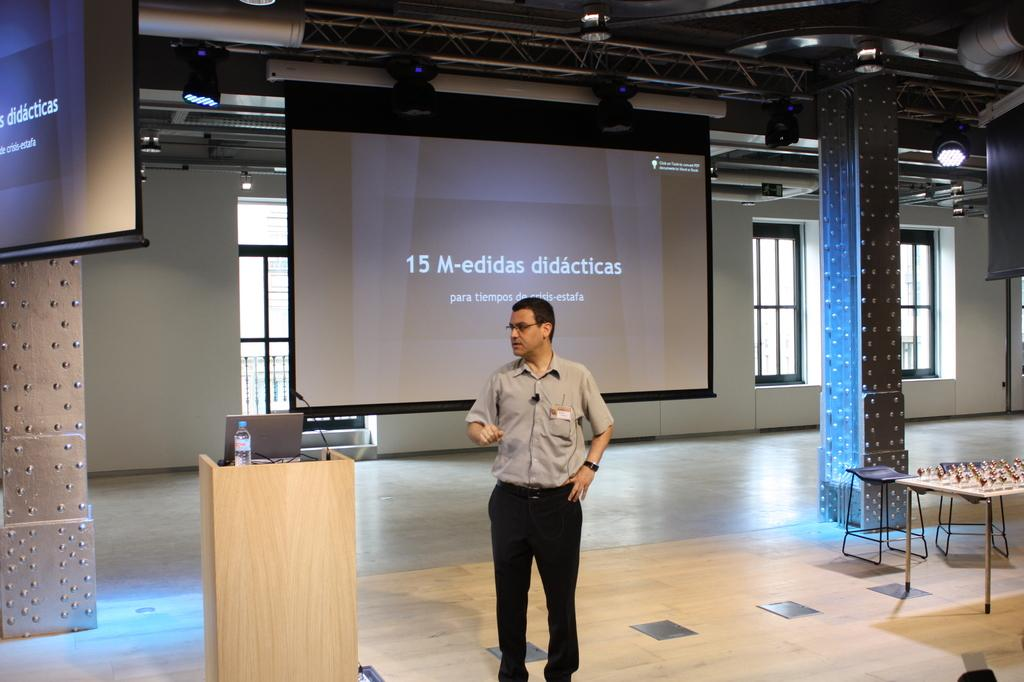<image>
Give a short and clear explanation of the subsequent image. A man standing in a building with 15 M-edidas didacticas on a screen. 